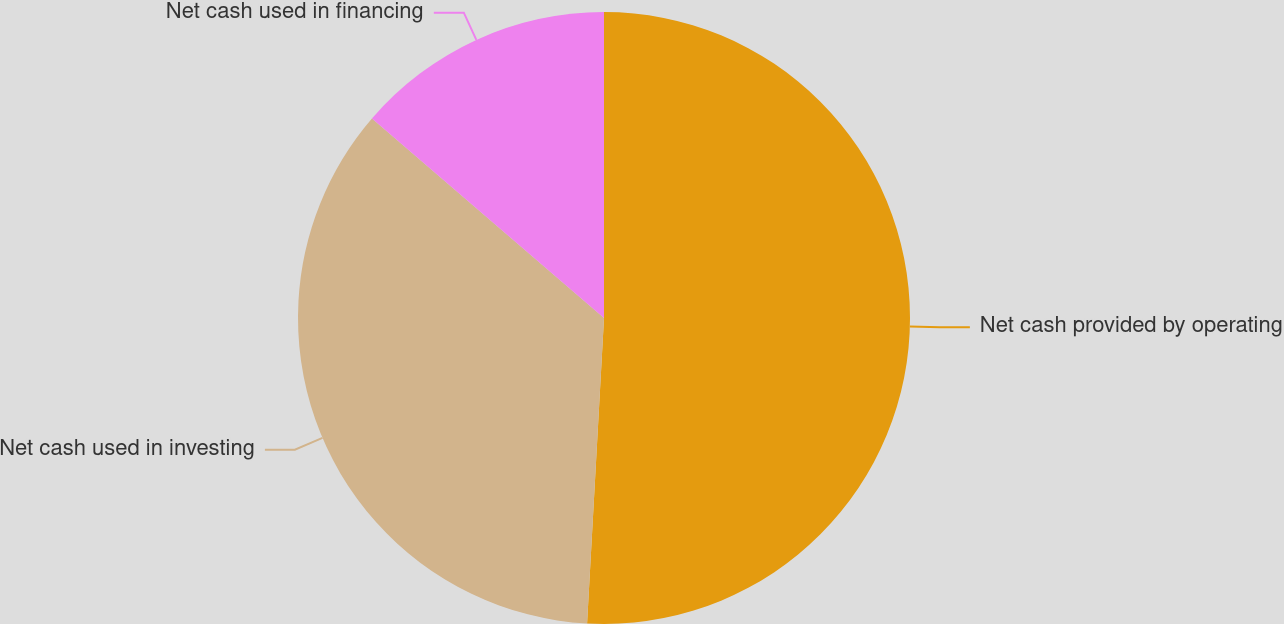Convert chart to OTSL. <chart><loc_0><loc_0><loc_500><loc_500><pie_chart><fcel>Net cash provided by operating<fcel>Net cash used in investing<fcel>Net cash used in financing<nl><fcel>50.88%<fcel>35.42%<fcel>13.7%<nl></chart> 